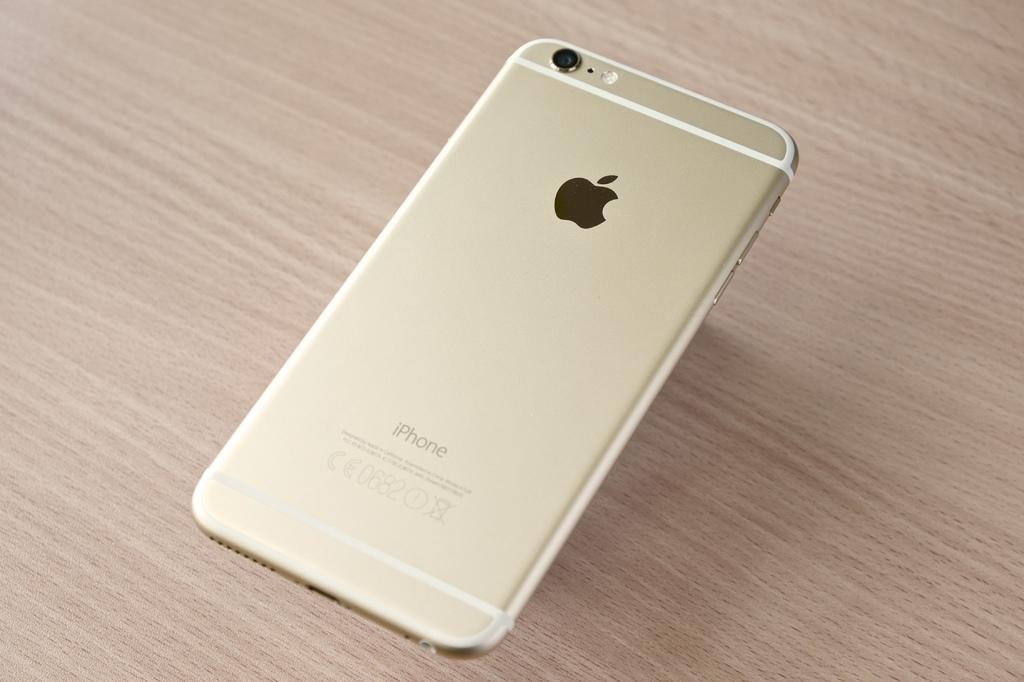<image>
Render a clear and concise summary of the photo. a phone that says iPhone on the back of it 